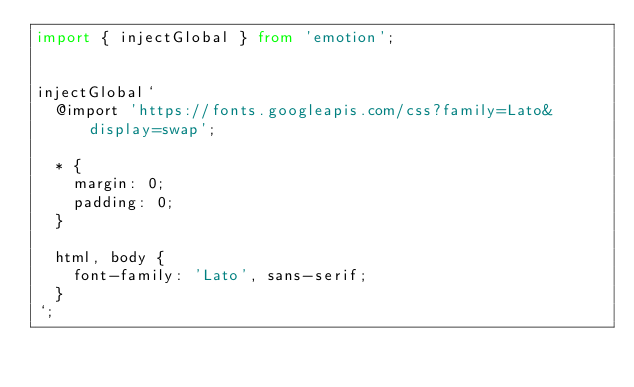Convert code to text. <code><loc_0><loc_0><loc_500><loc_500><_TypeScript_>import { injectGlobal } from 'emotion';


injectGlobal`
  @import 'https://fonts.googleapis.com/css?family=Lato&display=swap';

  * {
    margin: 0;
    padding: 0;
  }

  html, body {
    font-family: 'Lato', sans-serif;
  }
`;
</code> 